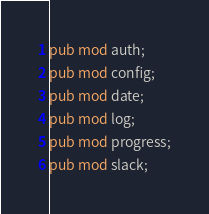Convert code to text. <code><loc_0><loc_0><loc_500><loc_500><_Rust_>pub mod auth;
pub mod config;
pub mod date;
pub mod log;
pub mod progress;
pub mod slack;
</code> 